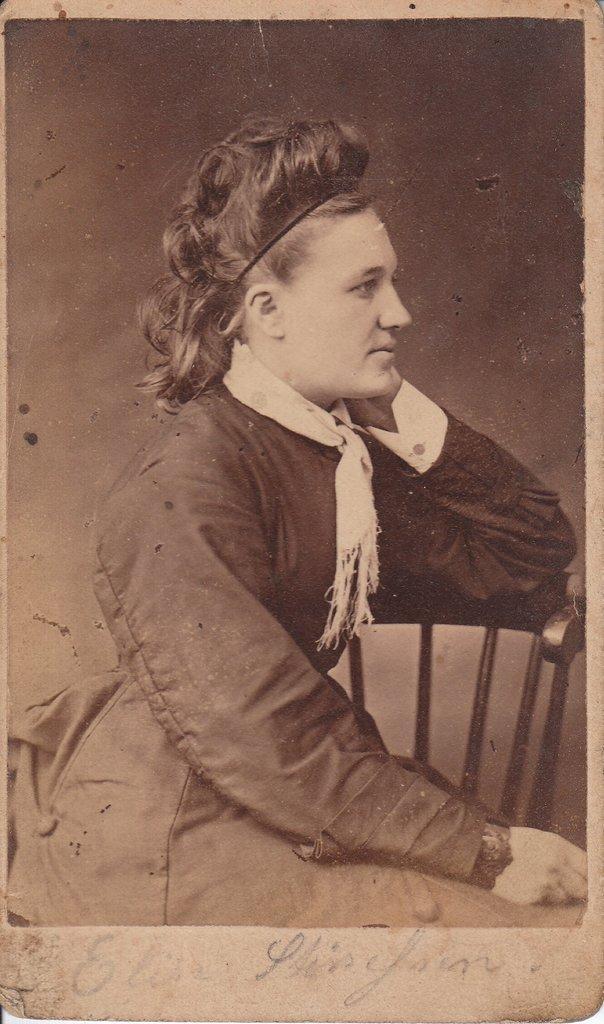How would you summarize this image in a sentence or two? In the picture we can see an old black and white photograph of a woman sitting on the chair and facing to the right hand side and keeping her hand on her neck and behind her we can see a wall. 